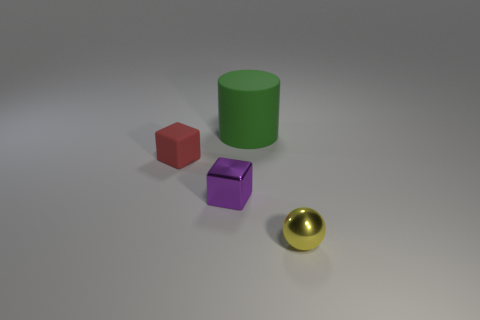Is the number of green rubber cylinders in front of the tiny shiny cube less than the number of purple things?
Keep it short and to the point. Yes. Do the red thing and the metallic object to the left of the large rubber cylinder have the same shape?
Your answer should be very brief. Yes. Are there any big yellow cylinders made of the same material as the small purple thing?
Offer a terse response. No. Are there any blocks behind the metallic thing on the left side of the tiny object right of the large green matte object?
Your answer should be very brief. Yes. How many other things are there of the same shape as the yellow metal object?
Offer a terse response. 0. What color is the rubber thing that is behind the small block that is left of the tiny metallic thing that is behind the tiny yellow object?
Offer a terse response. Green. What number of brown blocks are there?
Your answer should be very brief. 0. What number of big things are either red metal blocks or purple metal blocks?
Offer a very short reply. 0. What is the shape of the rubber thing that is the same size as the yellow metallic thing?
Provide a succinct answer. Cube. Is there anything else that is the same size as the green matte cylinder?
Provide a short and direct response. No. 